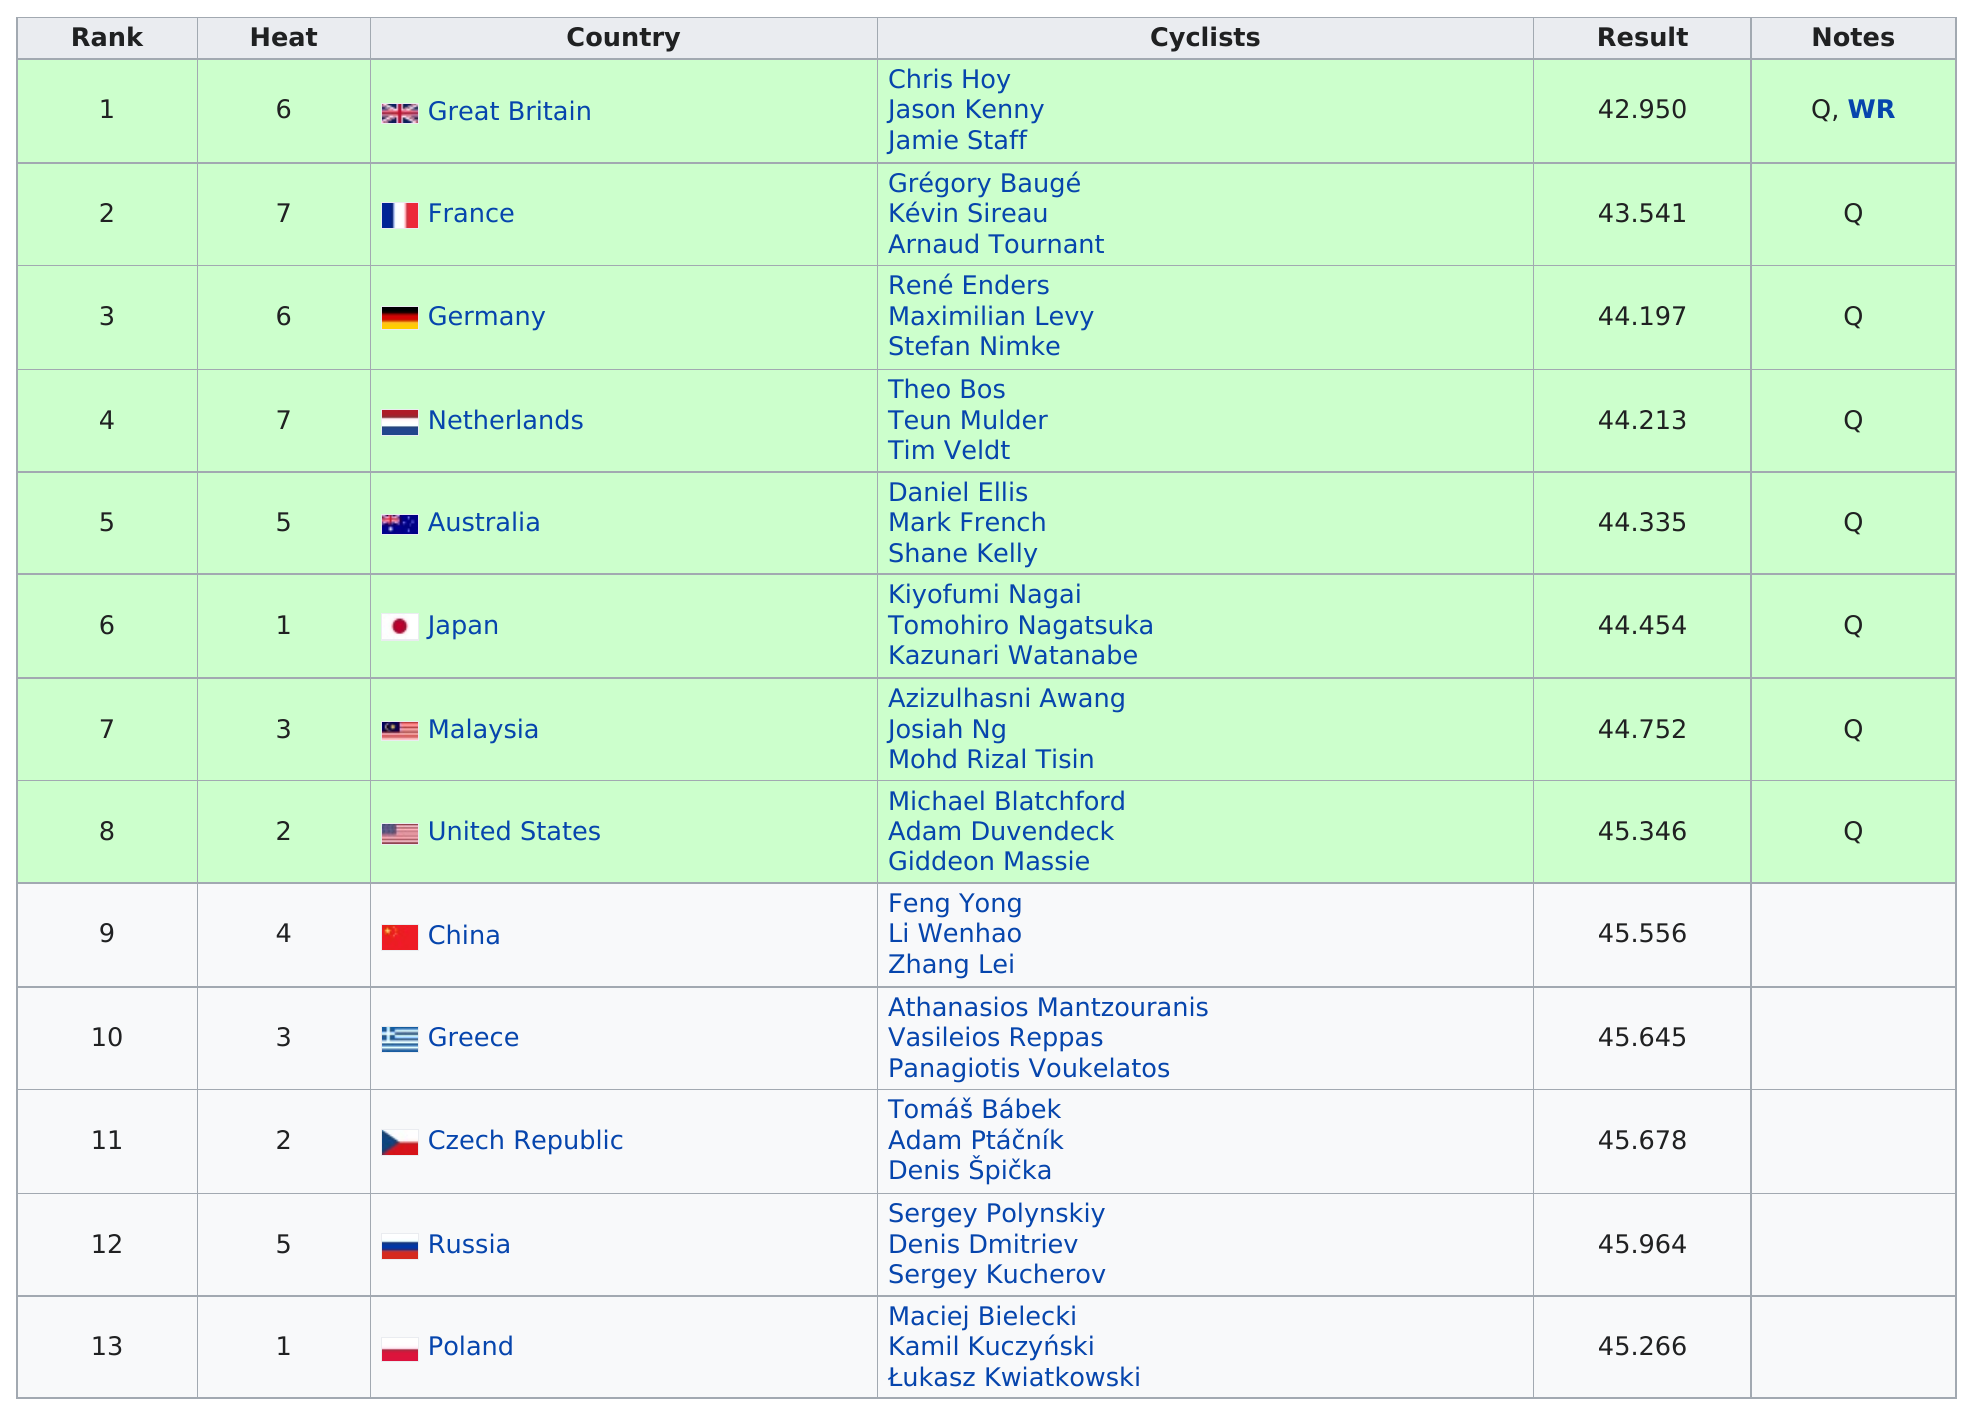Point out several critical features in this image. Germany was listed before Malaysia. All of the cyclists completed the race in a time of at least 45.266 seconds. Of the results, only 5 were not higher than the United States. After Josiah Ng, the team that finished directly after is the United States. A total of two cyclists finished the race in under 44 seconds. 